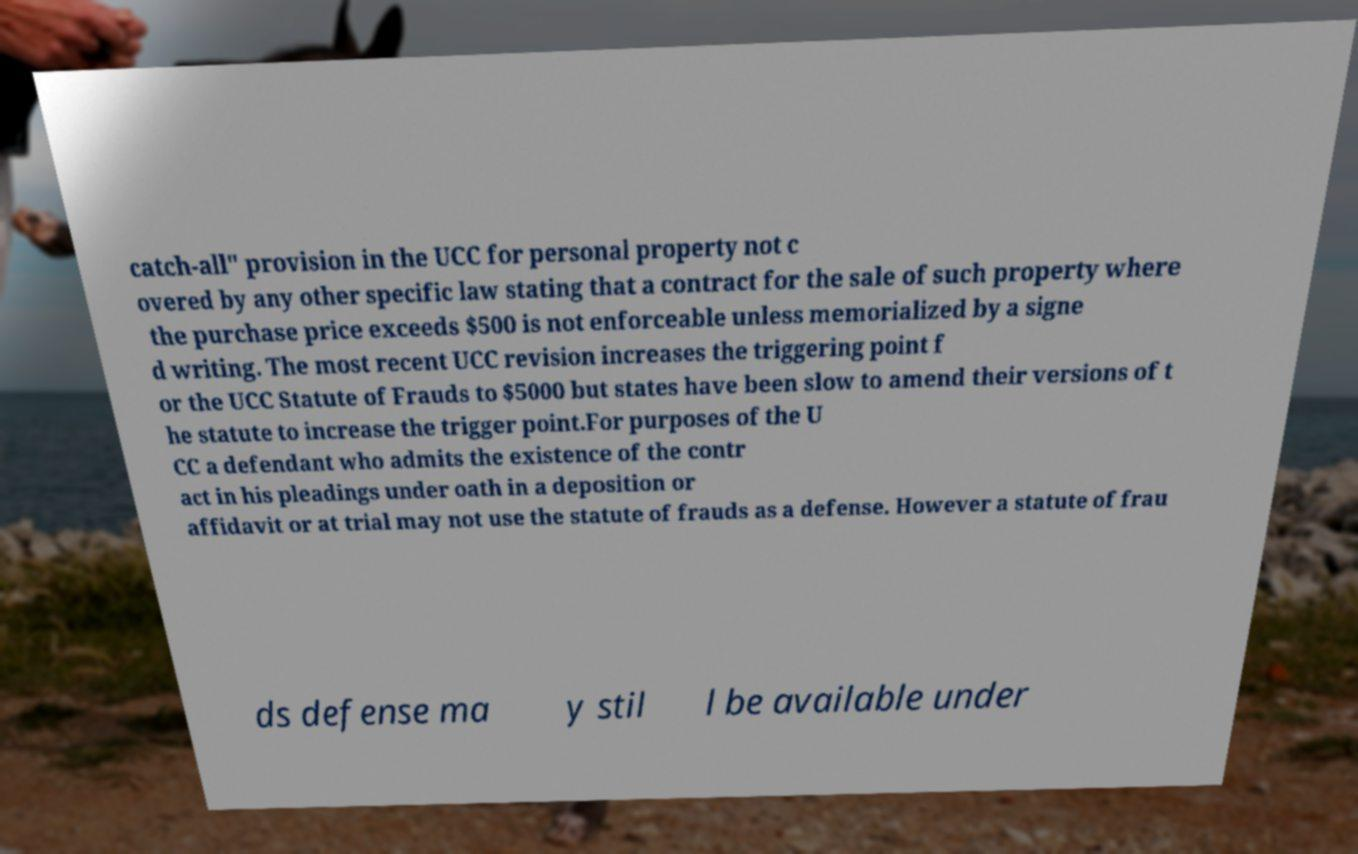Could you extract and type out the text from this image? catch-all" provision in the UCC for personal property not c overed by any other specific law stating that a contract for the sale of such property where the purchase price exceeds $500 is not enforceable unless memorialized by a signe d writing. The most recent UCC revision increases the triggering point f or the UCC Statute of Frauds to $5000 but states have been slow to amend their versions of t he statute to increase the trigger point.For purposes of the U CC a defendant who admits the existence of the contr act in his pleadings under oath in a deposition or affidavit or at trial may not use the statute of frauds as a defense. However a statute of frau ds defense ma y stil l be available under 